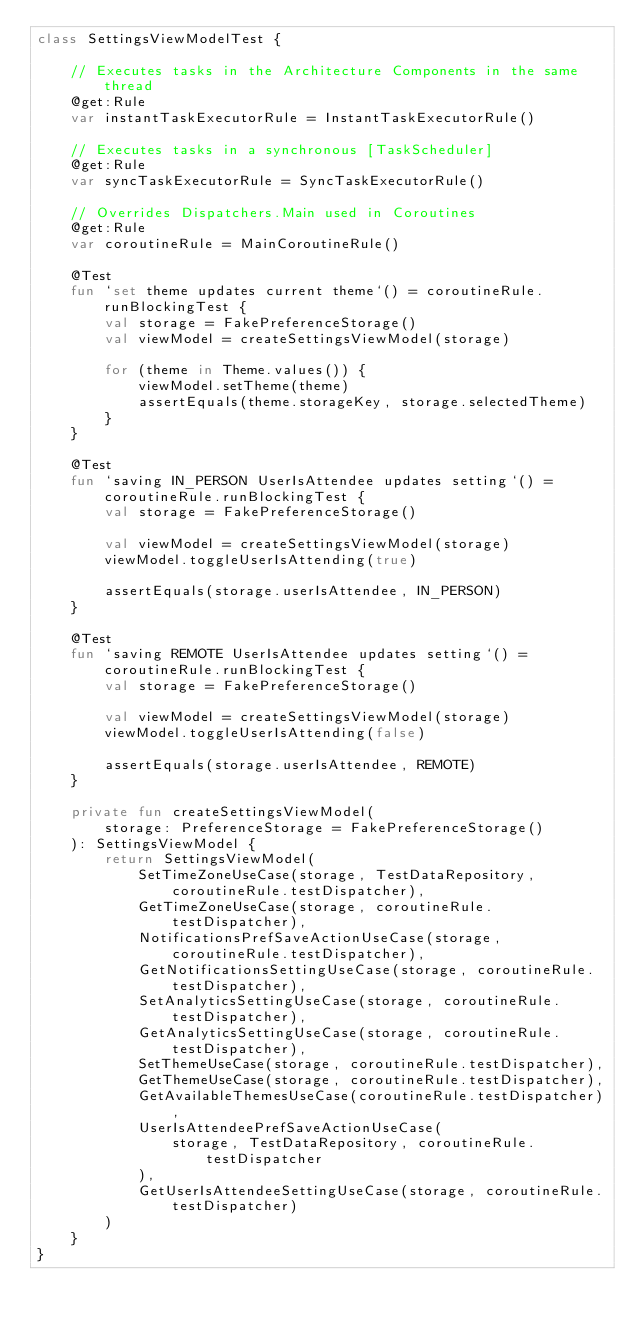Convert code to text. <code><loc_0><loc_0><loc_500><loc_500><_Kotlin_>class SettingsViewModelTest {

    // Executes tasks in the Architecture Components in the same thread
    @get:Rule
    var instantTaskExecutorRule = InstantTaskExecutorRule()

    // Executes tasks in a synchronous [TaskScheduler]
    @get:Rule
    var syncTaskExecutorRule = SyncTaskExecutorRule()

    // Overrides Dispatchers.Main used in Coroutines
    @get:Rule
    var coroutineRule = MainCoroutineRule()

    @Test
    fun `set theme updates current theme`() = coroutineRule.runBlockingTest {
        val storage = FakePreferenceStorage()
        val viewModel = createSettingsViewModel(storage)

        for (theme in Theme.values()) {
            viewModel.setTheme(theme)
            assertEquals(theme.storageKey, storage.selectedTheme)
        }
    }

    @Test
    fun `saving IN_PERSON UserIsAttendee updates setting`() = coroutineRule.runBlockingTest {
        val storage = FakePreferenceStorage()

        val viewModel = createSettingsViewModel(storage)
        viewModel.toggleUserIsAttending(true)

        assertEquals(storage.userIsAttendee, IN_PERSON)
    }

    @Test
    fun `saving REMOTE UserIsAttendee updates setting`() = coroutineRule.runBlockingTest {
        val storage = FakePreferenceStorage()

        val viewModel = createSettingsViewModel(storage)
        viewModel.toggleUserIsAttending(false)

        assertEquals(storage.userIsAttendee, REMOTE)
    }

    private fun createSettingsViewModel(
        storage: PreferenceStorage = FakePreferenceStorage()
    ): SettingsViewModel {
        return SettingsViewModel(
            SetTimeZoneUseCase(storage, TestDataRepository, coroutineRule.testDispatcher),
            GetTimeZoneUseCase(storage, coroutineRule.testDispatcher),
            NotificationsPrefSaveActionUseCase(storage, coroutineRule.testDispatcher),
            GetNotificationsSettingUseCase(storage, coroutineRule.testDispatcher),
            SetAnalyticsSettingUseCase(storage, coroutineRule.testDispatcher),
            GetAnalyticsSettingUseCase(storage, coroutineRule.testDispatcher),
            SetThemeUseCase(storage, coroutineRule.testDispatcher),
            GetThemeUseCase(storage, coroutineRule.testDispatcher),
            GetAvailableThemesUseCase(coroutineRule.testDispatcher),
            UserIsAttendeePrefSaveActionUseCase(
                storage, TestDataRepository, coroutineRule.testDispatcher
            ),
            GetUserIsAttendeeSettingUseCase(storage, coroutineRule.testDispatcher)
        )
    }
}
</code> 